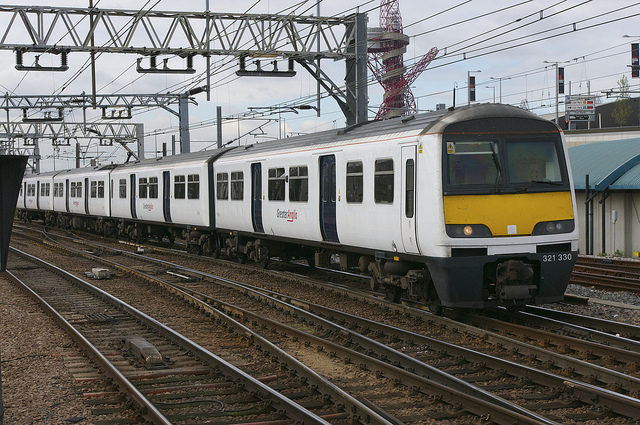Please transcribe the text information in this image. 321 330 